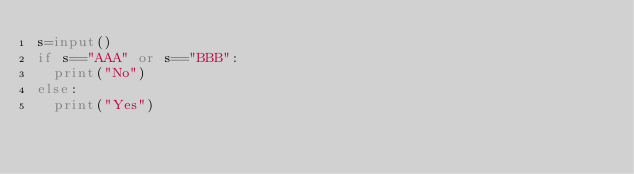<code> <loc_0><loc_0><loc_500><loc_500><_Python_>s=input()
if s=="AAA" or s=="BBB":
  print("No")
else:
  print("Yes")</code> 